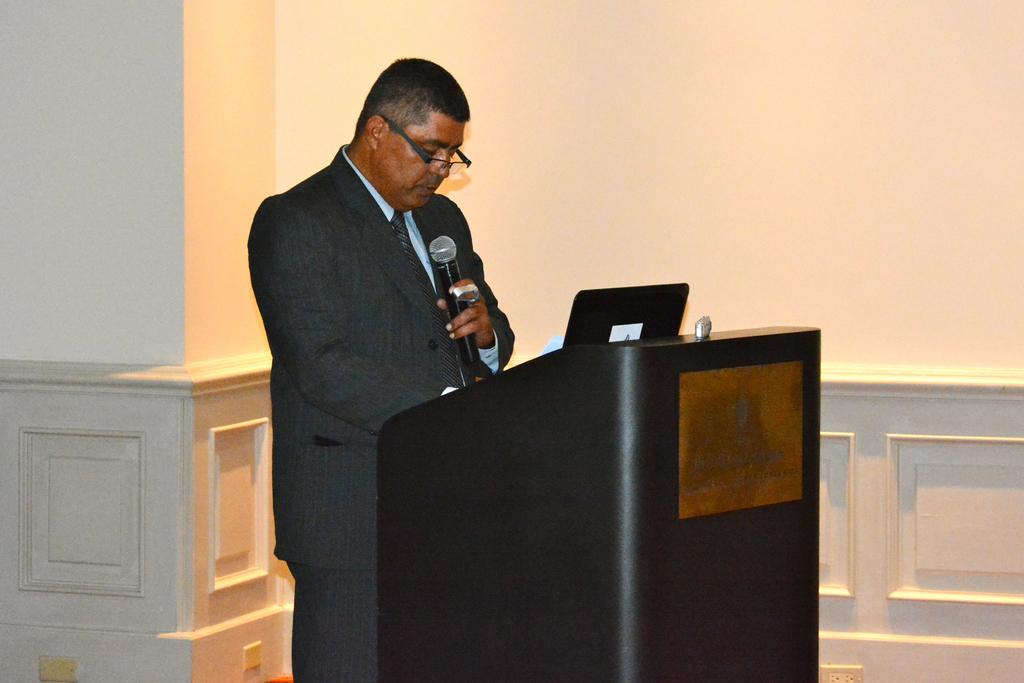What can be seen in the background of the image? There is a wall and a pillar in the background of the image. What is the man in the image doing? The man is standing in the image and holding a microphone in his hand. What is the man standing in front of? The man is standing in front of a podium. Can you describe the man's appearance? The man is wearing spectacles. Is the man wearing a veil in the image? No, the man is not wearing a veil in the image. What type of stew is being served at the event in the image? There is no event or stew present in the image; it features a man standing in front of a podium with a microphone. 